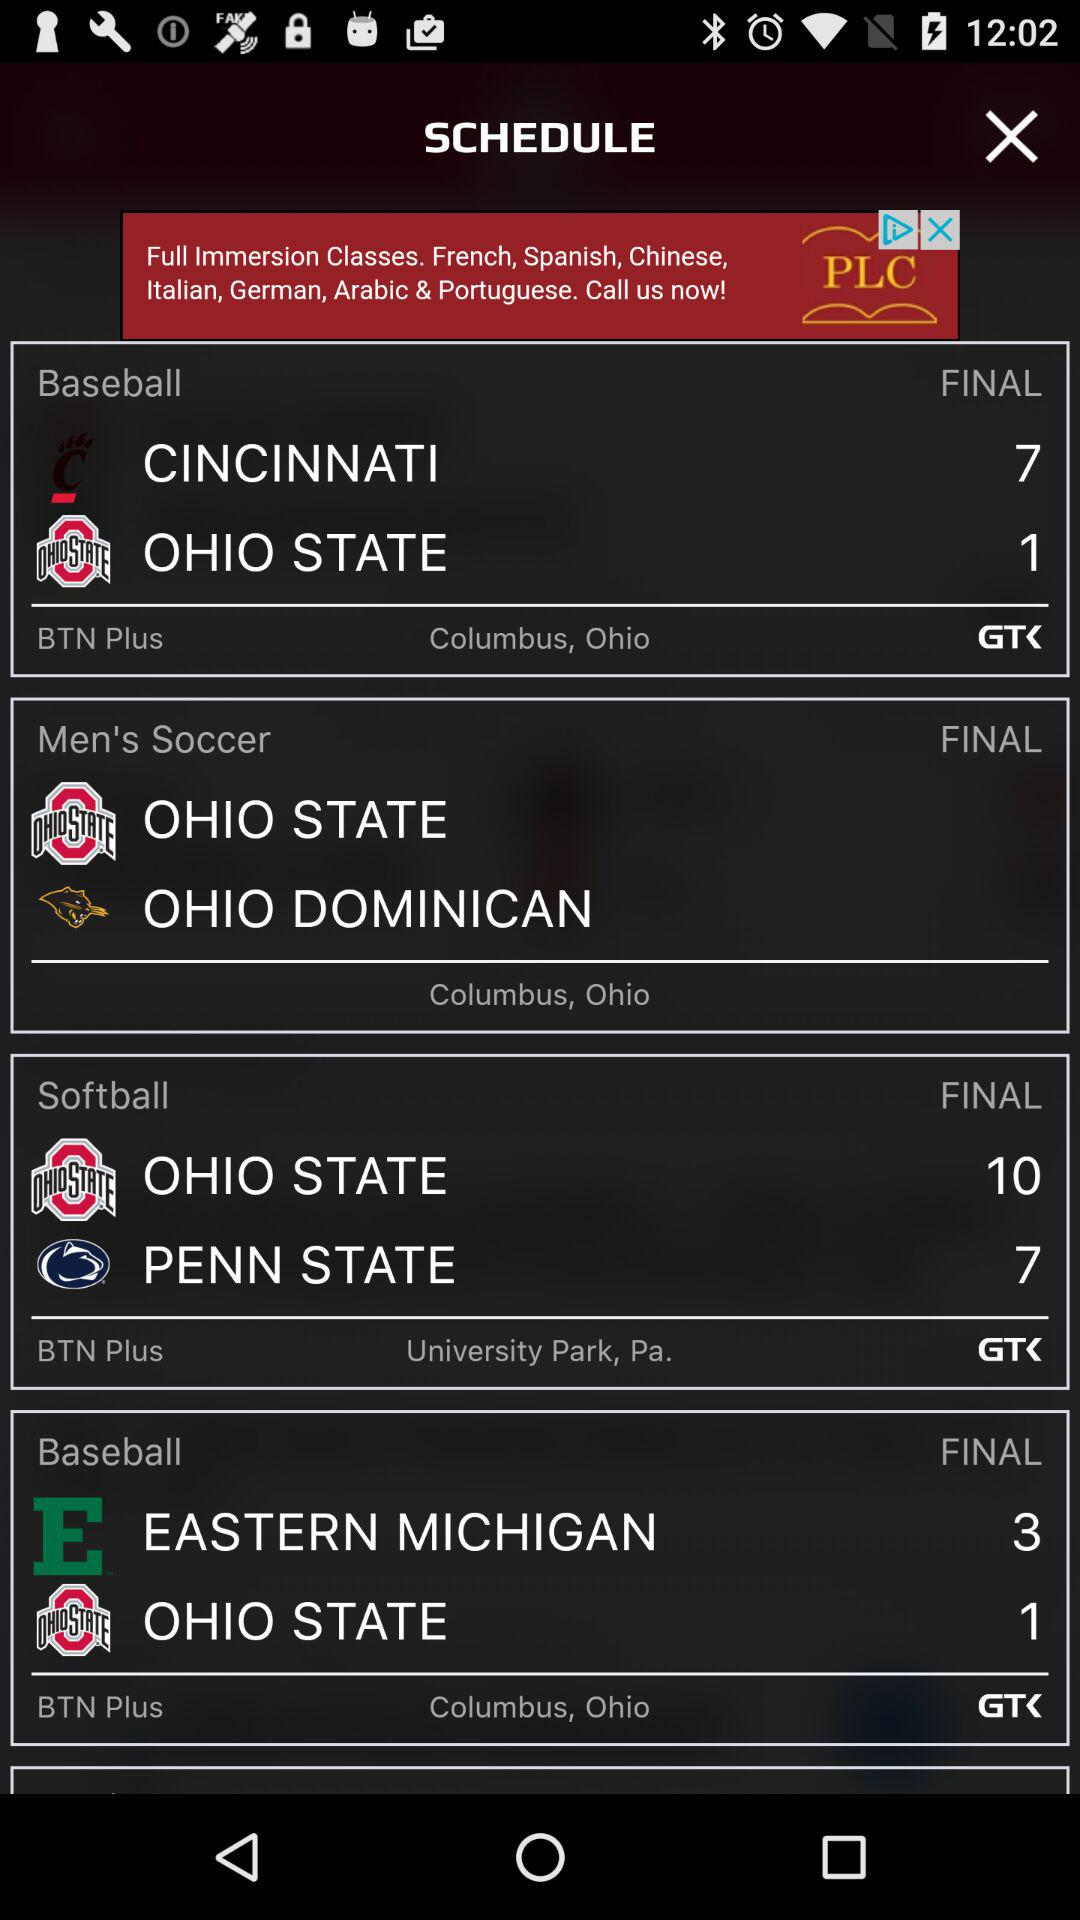Between which teams is the final match of "Men's Soccer"? The final match of "Men's Soccer" is between "OHIO STATE" and "OHIO DOMINICAN". 